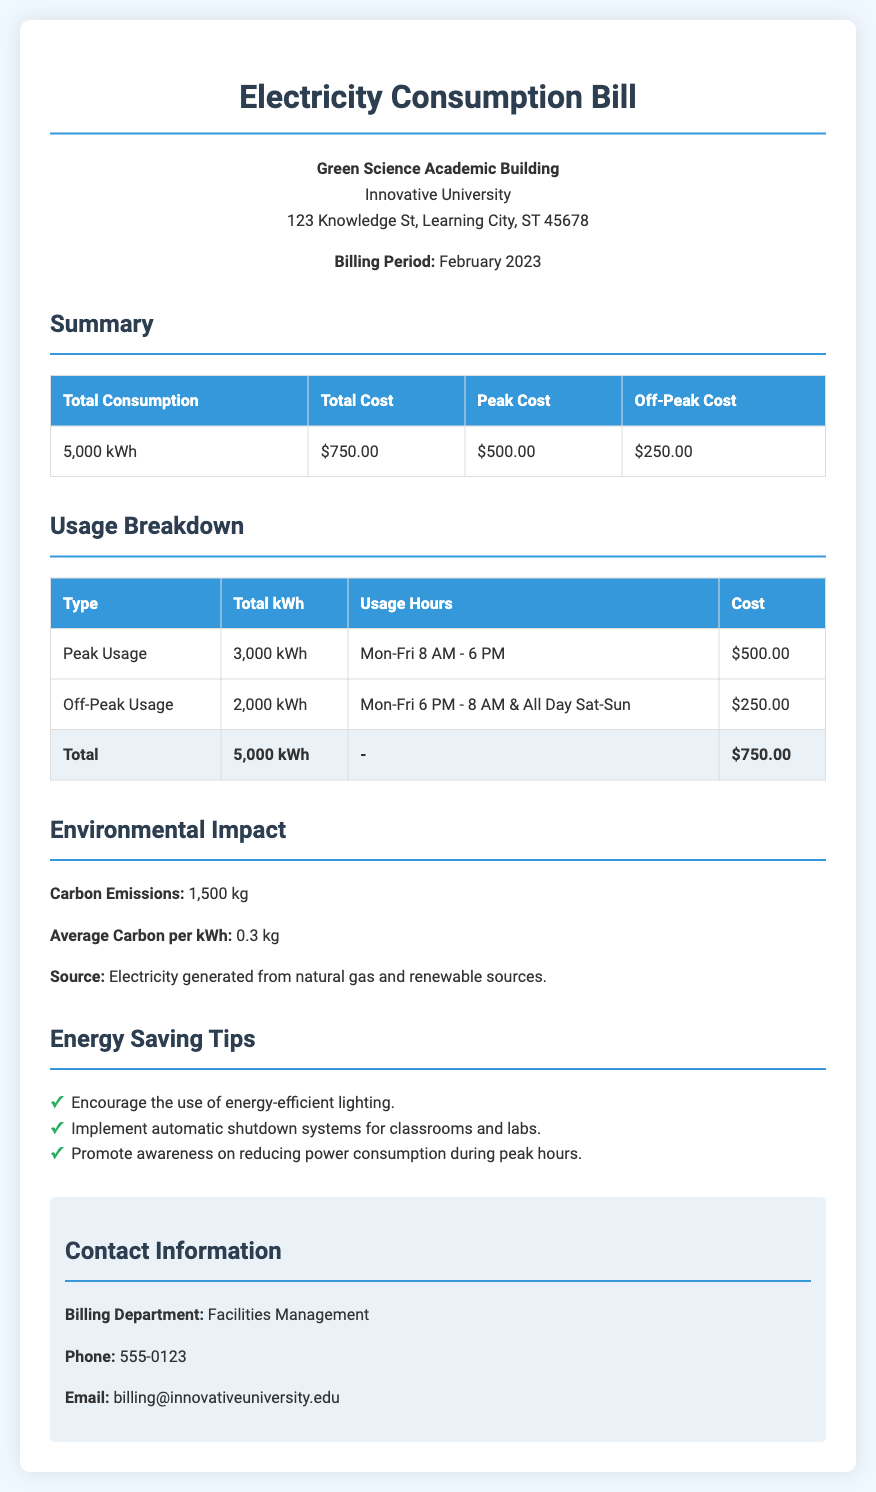What is the total consumption for February 2023? The total consumption is listed in the summary section of the document, which shows 5,000 kWh.
Answer: 5,000 kWh What is the total cost of the electricity? The total cost is reported in the summary section, which indicates $750.00.
Answer: $750.00 How much does peak usage cost? The peak usage cost is found in the summary table, which states $500.00.
Answer: $500.00 What are the peak usage hours? The peak usage hours are specified in the usage breakdown, showing Mon-Fri 8 AM - 6 PM.
Answer: Mon-Fri 8 AM - 6 PM What is the carbon emission value indicated? The carbon emissions are detailed in the environmental impact section as 1,500 kg.
Answer: 1,500 kg What energy-saving tip is suggested in the document? The tips are listed in the energy-saving section, one of which is to encourage the use of energy-efficient lighting.
Answer: Encourage the use of energy-efficient lighting What type of energy sources are mentioned for electricity generation? The document specifies that electricity is generated from natural gas and renewable sources under the environmental impact section.
Answer: Natural gas and renewable sources How many kilowatt-hours were used during off-peak times? The off-peak usage is detailed in the usage breakdown, which states 2,000 kWh.
Answer: 2,000 kWh Who should be contacted for billing inquiries? The contact information section lists Facilities Management as the contact for billing inquiries.
Answer: Facilities Management 